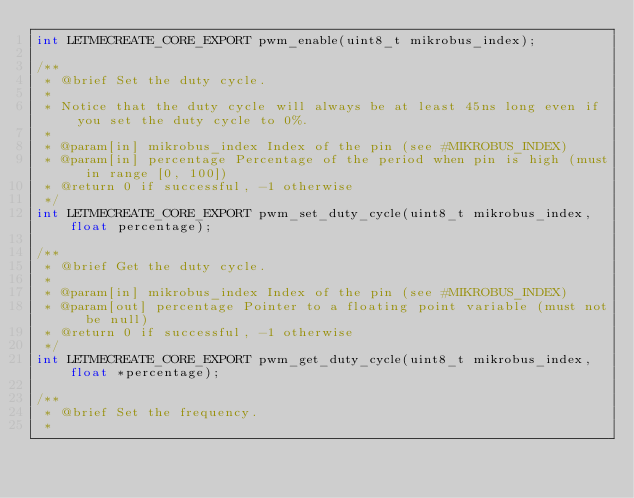Convert code to text. <code><loc_0><loc_0><loc_500><loc_500><_C_>int LETMECREATE_CORE_EXPORT pwm_enable(uint8_t mikrobus_index);

/**
 * @brief Set the duty cycle.
 *
 * Notice that the duty cycle will always be at least 45ns long even if you set the duty cycle to 0%.
 *
 * @param[in] mikrobus_index Index of the pin (see #MIKROBUS_INDEX)
 * @param[in] percentage Percentage of the period when pin is high (must in range [0, 100])
 * @return 0 if successful, -1 otherwise
 */
int LETMECREATE_CORE_EXPORT pwm_set_duty_cycle(uint8_t mikrobus_index, float percentage);

/**
 * @brief Get the duty cycle.
 *
 * @param[in] mikrobus_index Index of the pin (see #MIKROBUS_INDEX)
 * @param[out] percentage Pointer to a floating point variable (must not be null)
 * @return 0 if successful, -1 otherwise
 */
int LETMECREATE_CORE_EXPORT pwm_get_duty_cycle(uint8_t mikrobus_index, float *percentage);

/**
 * @brief Set the frequency.
 *</code> 